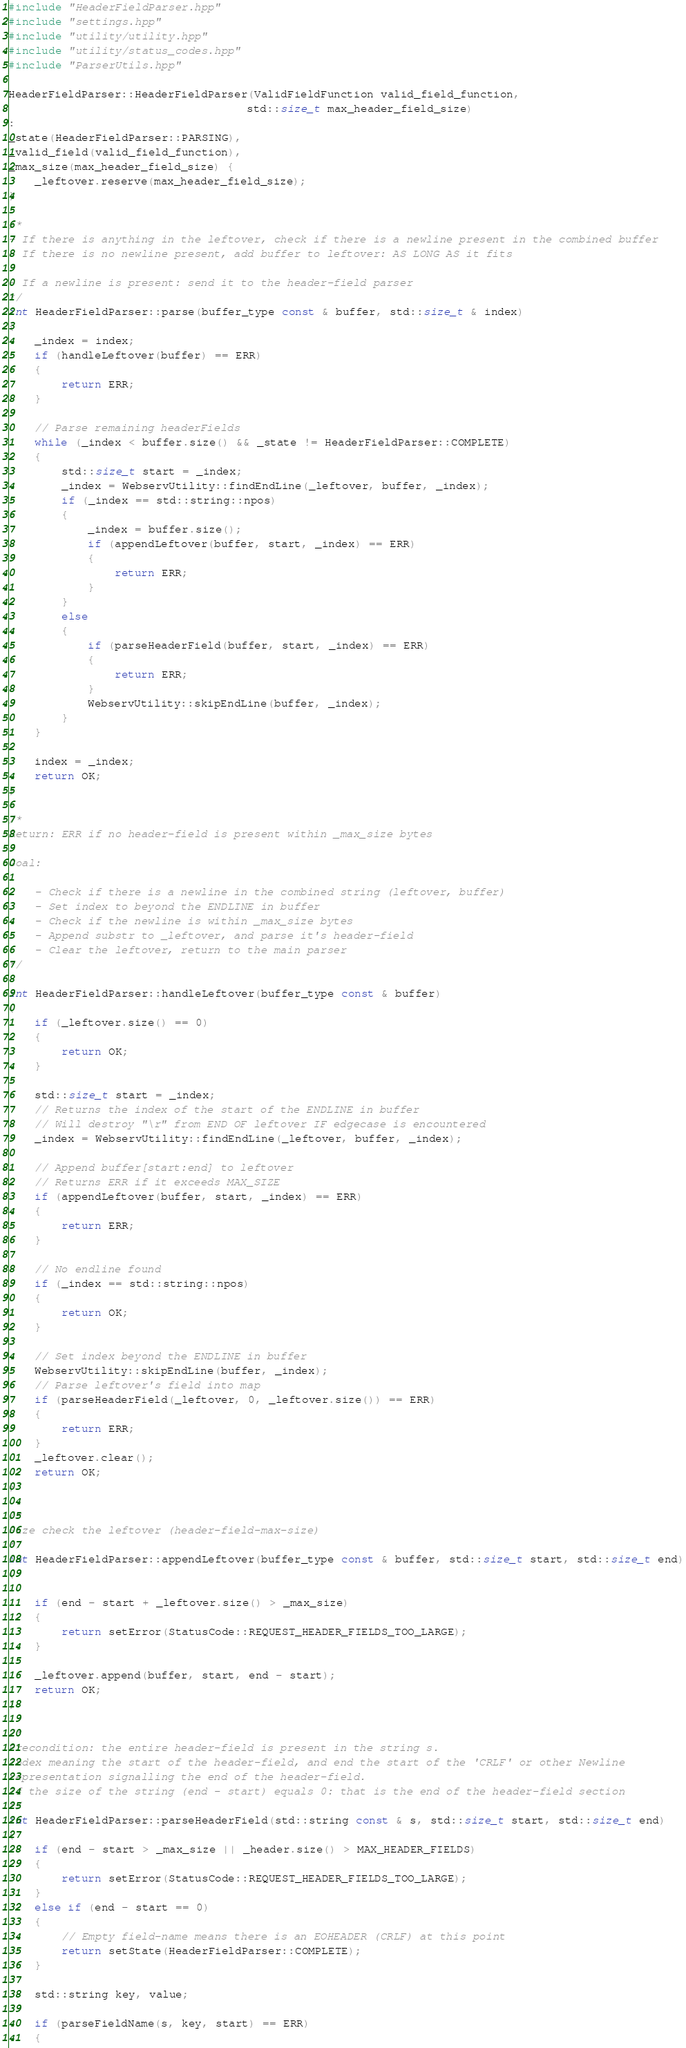Convert code to text. <code><loc_0><loc_0><loc_500><loc_500><_C++_>#include "HeaderFieldParser.hpp"
#include "settings.hpp"
#include "utility/utility.hpp"
#include "utility/status_codes.hpp"
#include "ParserUtils.hpp"

HeaderFieldParser::HeaderFieldParser(ValidFieldFunction valid_field_function,
									std::size_t max_header_field_size)
:
_state(HeaderFieldParser::PARSING),
_valid_field(valid_field_function),
_max_size(max_header_field_size) {
	_leftover.reserve(max_header_field_size);
}

/*
- If there is anything in the leftover, check if there is a newline present in the combined buffer
- If there is no newline present, add buffer to leftover: AS LONG AS it fits

- If a newline is present: send it to the header-field parser
*/
int HeaderFieldParser::parse(buffer_type const & buffer, std::size_t & index)
{
	_index = index;
	if (handleLeftover(buffer) == ERR)
	{
		return ERR;
	}

	// Parse remaining headerFields
	while (_index < buffer.size() && _state != HeaderFieldParser::COMPLETE)
	{
		std::size_t start = _index;
		_index = WebservUtility::findEndLine(_leftover, buffer, _index);
		if (_index == std::string::npos)
		{
			_index = buffer.size();
			if (appendLeftover(buffer, start, _index) == ERR)
			{
				return ERR;
			}
		}
		else
		{
			if (parseHeaderField(buffer, start, _index) == ERR)
			{
				return ERR;
			}
			WebservUtility::skipEndLine(buffer, _index);
		}
	}

	index = _index;
	return OK;
}

/*
Return: ERR if no header-field is present within _max_size bytes

Goal:

	- Check if there is a newline in the combined string (leftover, buffer)
	- Set index to beyond the ENDLINE in buffer
	- Check if the newline is within _max_size bytes
	- Append substr to _leftover, and parse it's header-field
	- Clear the leftover, return to the main parser
*/

int HeaderFieldParser::handleLeftover(buffer_type const & buffer)
{
	if (_leftover.size() == 0)
	{
		return OK;
	}

	std::size_t start = _index;
	// Returns the index of the start of the ENDLINE in buffer
	// Will destroy "\r" from END OF leftover IF edgecase is encountered
	_index = WebservUtility::findEndLine(_leftover, buffer, _index);

	// Append buffer[start:end] to leftover
	// Returns ERR if it exceeds MAX_SIZE
	if (appendLeftover(buffer, start, _index) == ERR)
	{
		return ERR;
	}

	// No endline found
	if (_index == std::string::npos)
	{
		return OK;
	}

	// Set index beyond the ENDLINE in buffer
	WebservUtility::skipEndLine(buffer, _index);
	// Parse leftover's field into map
	if (parseHeaderField(_leftover, 0, _leftover.size()) == ERR)
	{
		return ERR;
	}
	_leftover.clear();
	return OK;
}

/*
Size check the leftover (header-field-max-size)
*/
int HeaderFieldParser::appendLeftover(buffer_type const & buffer, std::size_t start, std::size_t end)
{

	if (end - start + _leftover.size() > _max_size)
	{
		return setError(StatusCode::REQUEST_HEADER_FIELDS_TOO_LARGE);
	}

	_leftover.append(buffer, start, end - start);
	return OK;
}

/*
Precondition: the entire header-field is present in the string s.
Index meaning the start of the header-field, and end the start of the 'CRLF' or other Newline
representation signalling the end of the header-field.
If the size of the string (end - start) equals 0: that is the end of the header-field section
*/
int HeaderFieldParser::parseHeaderField(std::string const & s, std::size_t start, std::size_t end)
{
	if (end - start > _max_size || _header.size() > MAX_HEADER_FIELDS)
	{
		return setError(StatusCode::REQUEST_HEADER_FIELDS_TOO_LARGE);
	}
	else if (end - start == 0)
	{
		// Empty field-name means there is an EOHEADER (CRLF) at this point
		return setState(HeaderFieldParser::COMPLETE);
	}

	std::string key, value;

	if (parseFieldName(s, key, start) == ERR)
	{</code> 